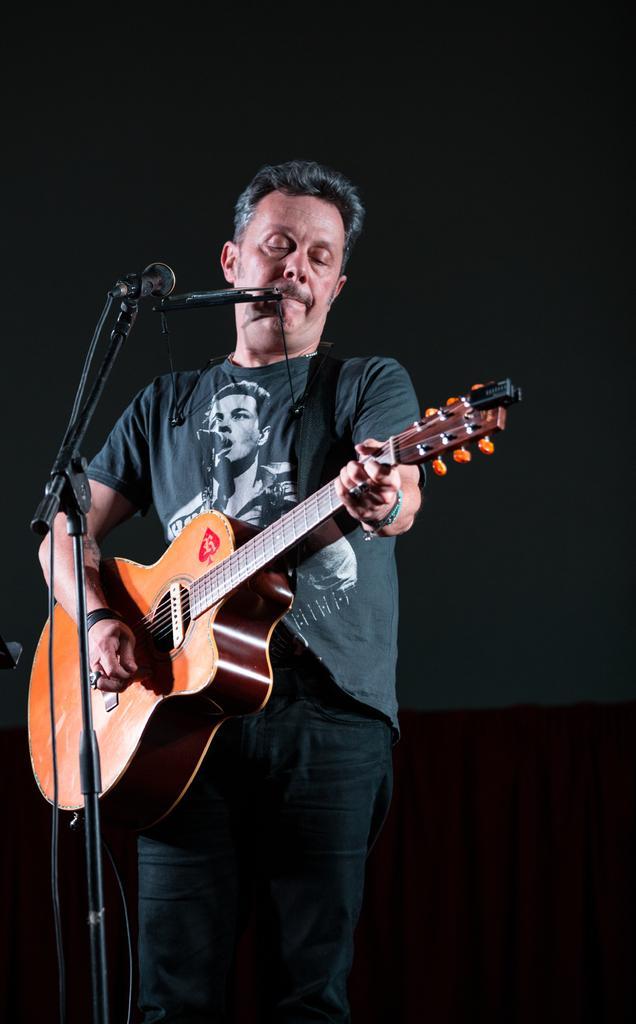How would you summarize this image in a sentence or two? This picture shows a man standing and playing guitar and we see a microphone in front of him 